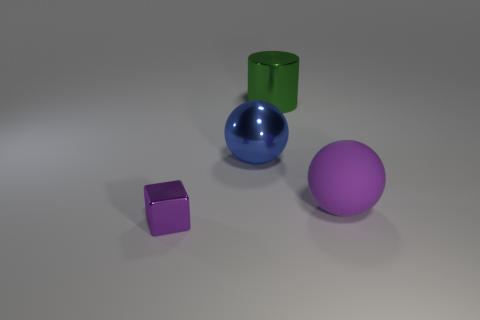Add 3 small blue shiny cylinders. How many objects exist? 7 Subtract all blocks. How many objects are left? 3 Add 4 large blue shiny spheres. How many large blue shiny spheres are left? 5 Add 4 rubber things. How many rubber things exist? 5 Subtract 0 yellow cylinders. How many objects are left? 4 Subtract all large blue metal balls. Subtract all purple shiny blocks. How many objects are left? 2 